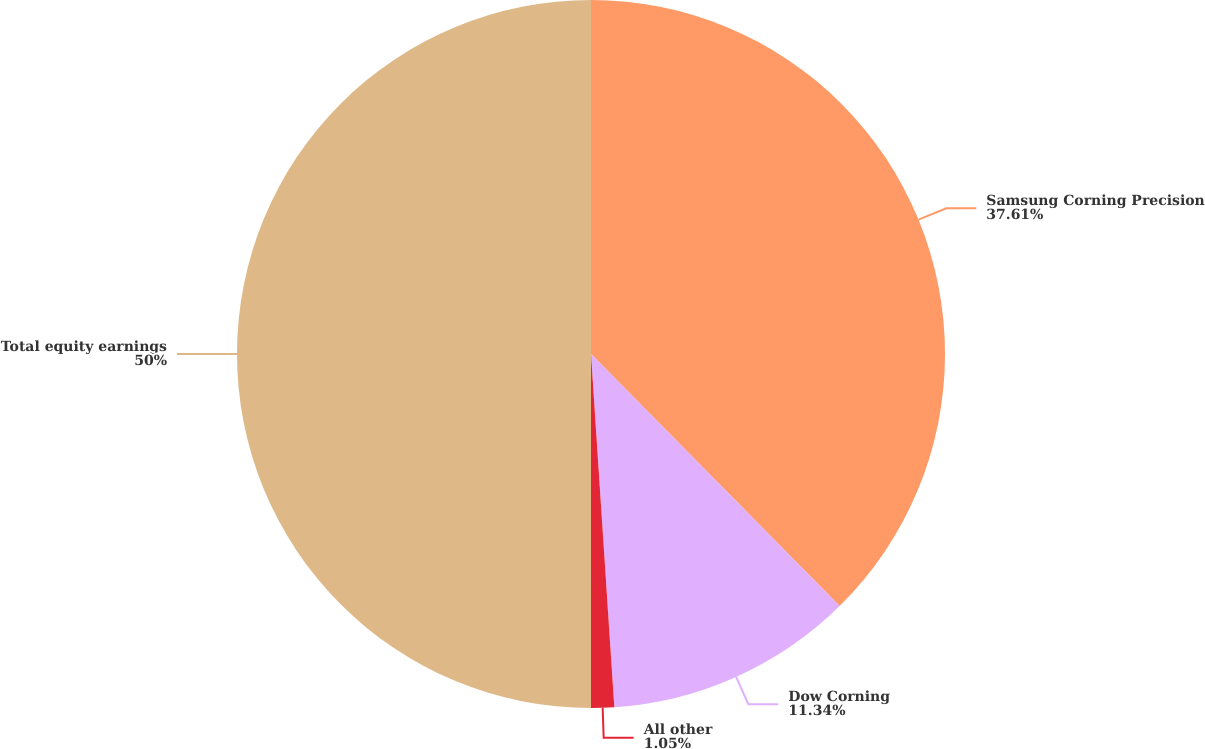Convert chart. <chart><loc_0><loc_0><loc_500><loc_500><pie_chart><fcel>Samsung Corning Precision<fcel>Dow Corning<fcel>All other<fcel>Total equity earnings<nl><fcel>37.61%<fcel>11.34%<fcel>1.05%<fcel>50.0%<nl></chart> 